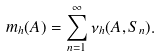Convert formula to latex. <formula><loc_0><loc_0><loc_500><loc_500>m _ { h } ( A ) = \sum _ { n = 1 } ^ { \infty } \nu _ { h } ( A , S _ { n } ) .</formula> 